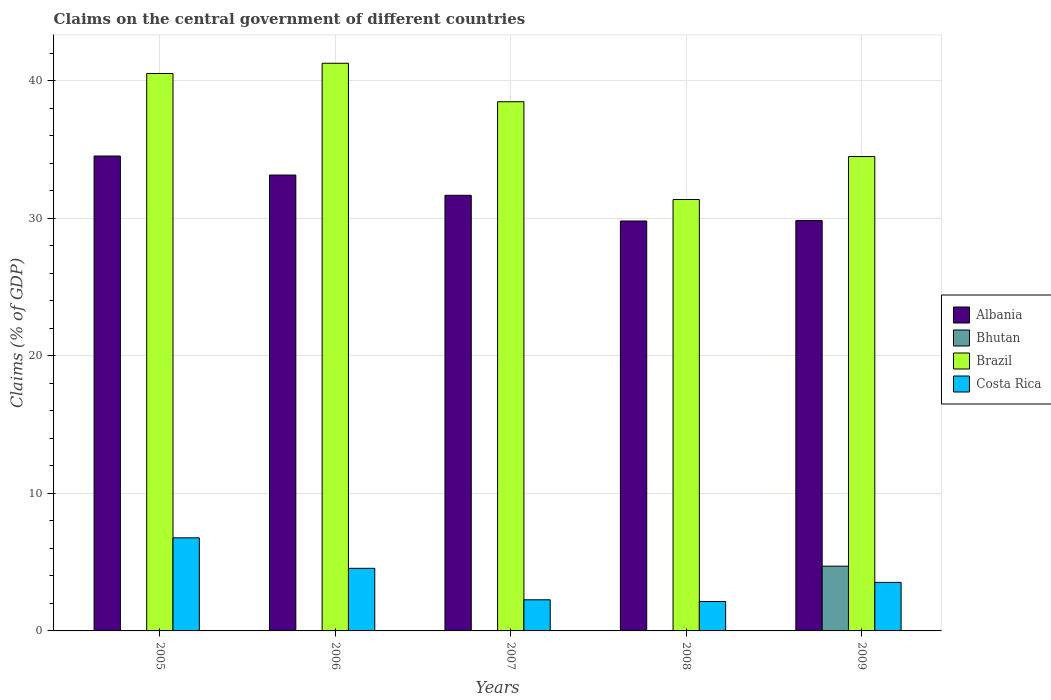How many different coloured bars are there?
Provide a short and direct response. 4. How many groups of bars are there?
Keep it short and to the point. 5. Are the number of bars per tick equal to the number of legend labels?
Provide a short and direct response. No. Are the number of bars on each tick of the X-axis equal?
Make the answer very short. No. How many bars are there on the 4th tick from the left?
Provide a succinct answer. 3. How many bars are there on the 4th tick from the right?
Give a very brief answer. 3. What is the percentage of GDP claimed on the central government in Brazil in 2005?
Give a very brief answer. 40.53. Across all years, what is the maximum percentage of GDP claimed on the central government in Brazil?
Ensure brevity in your answer.  41.27. Across all years, what is the minimum percentage of GDP claimed on the central government in Albania?
Keep it short and to the point. 29.8. In which year was the percentage of GDP claimed on the central government in Costa Rica maximum?
Your answer should be very brief. 2005. What is the total percentage of GDP claimed on the central government in Brazil in the graph?
Keep it short and to the point. 186.13. What is the difference between the percentage of GDP claimed on the central government in Costa Rica in 2005 and that in 2008?
Your response must be concise. 4.63. What is the difference between the percentage of GDP claimed on the central government in Albania in 2005 and the percentage of GDP claimed on the central government in Costa Rica in 2009?
Provide a short and direct response. 31. What is the average percentage of GDP claimed on the central government in Brazil per year?
Offer a very short reply. 37.23. In the year 2006, what is the difference between the percentage of GDP claimed on the central government in Costa Rica and percentage of GDP claimed on the central government in Brazil?
Provide a short and direct response. -36.72. What is the ratio of the percentage of GDP claimed on the central government in Brazil in 2006 to that in 2008?
Your response must be concise. 1.32. Is the percentage of GDP claimed on the central government in Costa Rica in 2006 less than that in 2009?
Your response must be concise. No. Is the difference between the percentage of GDP claimed on the central government in Costa Rica in 2005 and 2008 greater than the difference between the percentage of GDP claimed on the central government in Brazil in 2005 and 2008?
Offer a terse response. No. What is the difference between the highest and the second highest percentage of GDP claimed on the central government in Costa Rica?
Your response must be concise. 2.22. What is the difference between the highest and the lowest percentage of GDP claimed on the central government in Costa Rica?
Ensure brevity in your answer.  4.63. How many bars are there?
Provide a short and direct response. 16. Are all the bars in the graph horizontal?
Offer a very short reply. No. How many years are there in the graph?
Offer a terse response. 5. Does the graph contain any zero values?
Ensure brevity in your answer.  Yes. Does the graph contain grids?
Your answer should be very brief. Yes. How many legend labels are there?
Ensure brevity in your answer.  4. What is the title of the graph?
Offer a very short reply. Claims on the central government of different countries. Does "Madagascar" appear as one of the legend labels in the graph?
Make the answer very short. No. What is the label or title of the X-axis?
Your answer should be very brief. Years. What is the label or title of the Y-axis?
Offer a very short reply. Claims (% of GDP). What is the Claims (% of GDP) in Albania in 2005?
Offer a very short reply. 34.53. What is the Claims (% of GDP) of Bhutan in 2005?
Your answer should be compact. 0. What is the Claims (% of GDP) of Brazil in 2005?
Your answer should be very brief. 40.53. What is the Claims (% of GDP) of Costa Rica in 2005?
Your response must be concise. 6.77. What is the Claims (% of GDP) in Albania in 2006?
Keep it short and to the point. 33.14. What is the Claims (% of GDP) in Brazil in 2006?
Make the answer very short. 41.27. What is the Claims (% of GDP) in Costa Rica in 2006?
Offer a very short reply. 4.55. What is the Claims (% of GDP) of Albania in 2007?
Ensure brevity in your answer.  31.67. What is the Claims (% of GDP) in Bhutan in 2007?
Make the answer very short. 0. What is the Claims (% of GDP) in Brazil in 2007?
Provide a succinct answer. 38.47. What is the Claims (% of GDP) of Costa Rica in 2007?
Your answer should be very brief. 2.26. What is the Claims (% of GDP) of Albania in 2008?
Offer a terse response. 29.8. What is the Claims (% of GDP) in Brazil in 2008?
Provide a short and direct response. 31.37. What is the Claims (% of GDP) in Costa Rica in 2008?
Your answer should be compact. 2.14. What is the Claims (% of GDP) of Albania in 2009?
Offer a terse response. 29.83. What is the Claims (% of GDP) of Bhutan in 2009?
Provide a short and direct response. 4.71. What is the Claims (% of GDP) in Brazil in 2009?
Provide a succinct answer. 34.49. What is the Claims (% of GDP) in Costa Rica in 2009?
Ensure brevity in your answer.  3.53. Across all years, what is the maximum Claims (% of GDP) in Albania?
Offer a very short reply. 34.53. Across all years, what is the maximum Claims (% of GDP) of Bhutan?
Offer a terse response. 4.71. Across all years, what is the maximum Claims (% of GDP) of Brazil?
Provide a short and direct response. 41.27. Across all years, what is the maximum Claims (% of GDP) in Costa Rica?
Ensure brevity in your answer.  6.77. Across all years, what is the minimum Claims (% of GDP) of Albania?
Offer a very short reply. 29.8. Across all years, what is the minimum Claims (% of GDP) in Bhutan?
Offer a very short reply. 0. Across all years, what is the minimum Claims (% of GDP) of Brazil?
Offer a very short reply. 31.37. Across all years, what is the minimum Claims (% of GDP) of Costa Rica?
Ensure brevity in your answer.  2.14. What is the total Claims (% of GDP) of Albania in the graph?
Ensure brevity in your answer.  158.98. What is the total Claims (% of GDP) of Bhutan in the graph?
Offer a terse response. 4.71. What is the total Claims (% of GDP) of Brazil in the graph?
Make the answer very short. 186.13. What is the total Claims (% of GDP) of Costa Rica in the graph?
Your answer should be compact. 19.25. What is the difference between the Claims (% of GDP) in Albania in 2005 and that in 2006?
Give a very brief answer. 1.38. What is the difference between the Claims (% of GDP) in Brazil in 2005 and that in 2006?
Your response must be concise. -0.74. What is the difference between the Claims (% of GDP) of Costa Rica in 2005 and that in 2006?
Give a very brief answer. 2.22. What is the difference between the Claims (% of GDP) of Albania in 2005 and that in 2007?
Your answer should be very brief. 2.86. What is the difference between the Claims (% of GDP) in Brazil in 2005 and that in 2007?
Offer a terse response. 2.05. What is the difference between the Claims (% of GDP) of Costa Rica in 2005 and that in 2007?
Provide a short and direct response. 4.5. What is the difference between the Claims (% of GDP) in Albania in 2005 and that in 2008?
Offer a very short reply. 4.72. What is the difference between the Claims (% of GDP) of Brazil in 2005 and that in 2008?
Provide a short and direct response. 9.16. What is the difference between the Claims (% of GDP) in Costa Rica in 2005 and that in 2008?
Give a very brief answer. 4.63. What is the difference between the Claims (% of GDP) in Albania in 2005 and that in 2009?
Give a very brief answer. 4.69. What is the difference between the Claims (% of GDP) in Brazil in 2005 and that in 2009?
Your answer should be compact. 6.04. What is the difference between the Claims (% of GDP) of Costa Rica in 2005 and that in 2009?
Ensure brevity in your answer.  3.24. What is the difference between the Claims (% of GDP) in Albania in 2006 and that in 2007?
Offer a very short reply. 1.47. What is the difference between the Claims (% of GDP) of Brazil in 2006 and that in 2007?
Your response must be concise. 2.8. What is the difference between the Claims (% of GDP) of Costa Rica in 2006 and that in 2007?
Offer a very short reply. 2.29. What is the difference between the Claims (% of GDP) in Albania in 2006 and that in 2008?
Your answer should be compact. 3.34. What is the difference between the Claims (% of GDP) in Brazil in 2006 and that in 2008?
Offer a very short reply. 9.91. What is the difference between the Claims (% of GDP) in Costa Rica in 2006 and that in 2008?
Your response must be concise. 2.41. What is the difference between the Claims (% of GDP) in Albania in 2006 and that in 2009?
Offer a very short reply. 3.31. What is the difference between the Claims (% of GDP) in Brazil in 2006 and that in 2009?
Your answer should be compact. 6.78. What is the difference between the Claims (% of GDP) of Costa Rica in 2006 and that in 2009?
Provide a succinct answer. 1.02. What is the difference between the Claims (% of GDP) in Albania in 2007 and that in 2008?
Give a very brief answer. 1.87. What is the difference between the Claims (% of GDP) in Brazil in 2007 and that in 2008?
Make the answer very short. 7.11. What is the difference between the Claims (% of GDP) in Costa Rica in 2007 and that in 2008?
Provide a succinct answer. 0.12. What is the difference between the Claims (% of GDP) of Albania in 2007 and that in 2009?
Your answer should be compact. 1.84. What is the difference between the Claims (% of GDP) in Brazil in 2007 and that in 2009?
Keep it short and to the point. 3.98. What is the difference between the Claims (% of GDP) in Costa Rica in 2007 and that in 2009?
Keep it short and to the point. -1.27. What is the difference between the Claims (% of GDP) in Albania in 2008 and that in 2009?
Offer a terse response. -0.03. What is the difference between the Claims (% of GDP) in Brazil in 2008 and that in 2009?
Provide a short and direct response. -3.12. What is the difference between the Claims (% of GDP) in Costa Rica in 2008 and that in 2009?
Offer a very short reply. -1.39. What is the difference between the Claims (% of GDP) of Albania in 2005 and the Claims (% of GDP) of Brazil in 2006?
Your answer should be very brief. -6.75. What is the difference between the Claims (% of GDP) in Albania in 2005 and the Claims (% of GDP) in Costa Rica in 2006?
Your answer should be compact. 29.98. What is the difference between the Claims (% of GDP) in Brazil in 2005 and the Claims (% of GDP) in Costa Rica in 2006?
Offer a terse response. 35.98. What is the difference between the Claims (% of GDP) in Albania in 2005 and the Claims (% of GDP) in Brazil in 2007?
Keep it short and to the point. -3.95. What is the difference between the Claims (% of GDP) in Albania in 2005 and the Claims (% of GDP) in Costa Rica in 2007?
Your response must be concise. 32.26. What is the difference between the Claims (% of GDP) in Brazil in 2005 and the Claims (% of GDP) in Costa Rica in 2007?
Ensure brevity in your answer.  38.27. What is the difference between the Claims (% of GDP) of Albania in 2005 and the Claims (% of GDP) of Brazil in 2008?
Give a very brief answer. 3.16. What is the difference between the Claims (% of GDP) of Albania in 2005 and the Claims (% of GDP) of Costa Rica in 2008?
Give a very brief answer. 32.39. What is the difference between the Claims (% of GDP) in Brazil in 2005 and the Claims (% of GDP) in Costa Rica in 2008?
Your answer should be compact. 38.39. What is the difference between the Claims (% of GDP) in Albania in 2005 and the Claims (% of GDP) in Bhutan in 2009?
Ensure brevity in your answer.  29.82. What is the difference between the Claims (% of GDP) in Albania in 2005 and the Claims (% of GDP) in Brazil in 2009?
Ensure brevity in your answer.  0.04. What is the difference between the Claims (% of GDP) in Albania in 2005 and the Claims (% of GDP) in Costa Rica in 2009?
Make the answer very short. 31. What is the difference between the Claims (% of GDP) in Brazil in 2005 and the Claims (% of GDP) in Costa Rica in 2009?
Your response must be concise. 37. What is the difference between the Claims (% of GDP) in Albania in 2006 and the Claims (% of GDP) in Brazil in 2007?
Offer a terse response. -5.33. What is the difference between the Claims (% of GDP) in Albania in 2006 and the Claims (% of GDP) in Costa Rica in 2007?
Provide a short and direct response. 30.88. What is the difference between the Claims (% of GDP) of Brazil in 2006 and the Claims (% of GDP) of Costa Rica in 2007?
Ensure brevity in your answer.  39.01. What is the difference between the Claims (% of GDP) in Albania in 2006 and the Claims (% of GDP) in Brazil in 2008?
Provide a succinct answer. 1.78. What is the difference between the Claims (% of GDP) in Albania in 2006 and the Claims (% of GDP) in Costa Rica in 2008?
Provide a succinct answer. 31. What is the difference between the Claims (% of GDP) in Brazil in 2006 and the Claims (% of GDP) in Costa Rica in 2008?
Ensure brevity in your answer.  39.13. What is the difference between the Claims (% of GDP) of Albania in 2006 and the Claims (% of GDP) of Bhutan in 2009?
Your answer should be compact. 28.43. What is the difference between the Claims (% of GDP) in Albania in 2006 and the Claims (% of GDP) in Brazil in 2009?
Provide a succinct answer. -1.35. What is the difference between the Claims (% of GDP) in Albania in 2006 and the Claims (% of GDP) in Costa Rica in 2009?
Ensure brevity in your answer.  29.61. What is the difference between the Claims (% of GDP) of Brazil in 2006 and the Claims (% of GDP) of Costa Rica in 2009?
Your answer should be compact. 37.74. What is the difference between the Claims (% of GDP) of Albania in 2007 and the Claims (% of GDP) of Brazil in 2008?
Ensure brevity in your answer.  0.31. What is the difference between the Claims (% of GDP) of Albania in 2007 and the Claims (% of GDP) of Costa Rica in 2008?
Offer a terse response. 29.53. What is the difference between the Claims (% of GDP) in Brazil in 2007 and the Claims (% of GDP) in Costa Rica in 2008?
Provide a succinct answer. 36.34. What is the difference between the Claims (% of GDP) of Albania in 2007 and the Claims (% of GDP) of Bhutan in 2009?
Your response must be concise. 26.96. What is the difference between the Claims (% of GDP) of Albania in 2007 and the Claims (% of GDP) of Brazil in 2009?
Ensure brevity in your answer.  -2.82. What is the difference between the Claims (% of GDP) in Albania in 2007 and the Claims (% of GDP) in Costa Rica in 2009?
Give a very brief answer. 28.14. What is the difference between the Claims (% of GDP) in Brazil in 2007 and the Claims (% of GDP) in Costa Rica in 2009?
Your answer should be compact. 34.95. What is the difference between the Claims (% of GDP) of Albania in 2008 and the Claims (% of GDP) of Bhutan in 2009?
Offer a very short reply. 25.09. What is the difference between the Claims (% of GDP) of Albania in 2008 and the Claims (% of GDP) of Brazil in 2009?
Your answer should be compact. -4.69. What is the difference between the Claims (% of GDP) of Albania in 2008 and the Claims (% of GDP) of Costa Rica in 2009?
Ensure brevity in your answer.  26.27. What is the difference between the Claims (% of GDP) of Brazil in 2008 and the Claims (% of GDP) of Costa Rica in 2009?
Your response must be concise. 27.84. What is the average Claims (% of GDP) of Albania per year?
Your answer should be compact. 31.8. What is the average Claims (% of GDP) of Bhutan per year?
Your answer should be compact. 0.94. What is the average Claims (% of GDP) of Brazil per year?
Make the answer very short. 37.23. What is the average Claims (% of GDP) of Costa Rica per year?
Make the answer very short. 3.85. In the year 2005, what is the difference between the Claims (% of GDP) in Albania and Claims (% of GDP) in Brazil?
Ensure brevity in your answer.  -6. In the year 2005, what is the difference between the Claims (% of GDP) of Albania and Claims (% of GDP) of Costa Rica?
Provide a succinct answer. 27.76. In the year 2005, what is the difference between the Claims (% of GDP) of Brazil and Claims (% of GDP) of Costa Rica?
Make the answer very short. 33.76. In the year 2006, what is the difference between the Claims (% of GDP) of Albania and Claims (% of GDP) of Brazil?
Offer a terse response. -8.13. In the year 2006, what is the difference between the Claims (% of GDP) of Albania and Claims (% of GDP) of Costa Rica?
Give a very brief answer. 28.59. In the year 2006, what is the difference between the Claims (% of GDP) in Brazil and Claims (% of GDP) in Costa Rica?
Offer a very short reply. 36.72. In the year 2007, what is the difference between the Claims (% of GDP) of Albania and Claims (% of GDP) of Brazil?
Your answer should be compact. -6.8. In the year 2007, what is the difference between the Claims (% of GDP) of Albania and Claims (% of GDP) of Costa Rica?
Your response must be concise. 29.41. In the year 2007, what is the difference between the Claims (% of GDP) of Brazil and Claims (% of GDP) of Costa Rica?
Ensure brevity in your answer.  36.21. In the year 2008, what is the difference between the Claims (% of GDP) in Albania and Claims (% of GDP) in Brazil?
Provide a short and direct response. -1.56. In the year 2008, what is the difference between the Claims (% of GDP) in Albania and Claims (% of GDP) in Costa Rica?
Offer a very short reply. 27.66. In the year 2008, what is the difference between the Claims (% of GDP) in Brazil and Claims (% of GDP) in Costa Rica?
Ensure brevity in your answer.  29.23. In the year 2009, what is the difference between the Claims (% of GDP) of Albania and Claims (% of GDP) of Bhutan?
Your answer should be very brief. 25.13. In the year 2009, what is the difference between the Claims (% of GDP) in Albania and Claims (% of GDP) in Brazil?
Offer a terse response. -4.66. In the year 2009, what is the difference between the Claims (% of GDP) of Albania and Claims (% of GDP) of Costa Rica?
Make the answer very short. 26.31. In the year 2009, what is the difference between the Claims (% of GDP) of Bhutan and Claims (% of GDP) of Brazil?
Offer a terse response. -29.78. In the year 2009, what is the difference between the Claims (% of GDP) of Bhutan and Claims (% of GDP) of Costa Rica?
Your answer should be very brief. 1.18. In the year 2009, what is the difference between the Claims (% of GDP) of Brazil and Claims (% of GDP) of Costa Rica?
Your answer should be very brief. 30.96. What is the ratio of the Claims (% of GDP) of Albania in 2005 to that in 2006?
Your response must be concise. 1.04. What is the ratio of the Claims (% of GDP) of Costa Rica in 2005 to that in 2006?
Offer a very short reply. 1.49. What is the ratio of the Claims (% of GDP) of Albania in 2005 to that in 2007?
Your response must be concise. 1.09. What is the ratio of the Claims (% of GDP) of Brazil in 2005 to that in 2007?
Offer a terse response. 1.05. What is the ratio of the Claims (% of GDP) in Costa Rica in 2005 to that in 2007?
Your response must be concise. 2.99. What is the ratio of the Claims (% of GDP) of Albania in 2005 to that in 2008?
Your response must be concise. 1.16. What is the ratio of the Claims (% of GDP) in Brazil in 2005 to that in 2008?
Your response must be concise. 1.29. What is the ratio of the Claims (% of GDP) in Costa Rica in 2005 to that in 2008?
Your answer should be compact. 3.16. What is the ratio of the Claims (% of GDP) in Albania in 2005 to that in 2009?
Give a very brief answer. 1.16. What is the ratio of the Claims (% of GDP) in Brazil in 2005 to that in 2009?
Your answer should be very brief. 1.18. What is the ratio of the Claims (% of GDP) in Costa Rica in 2005 to that in 2009?
Offer a very short reply. 1.92. What is the ratio of the Claims (% of GDP) of Albania in 2006 to that in 2007?
Ensure brevity in your answer.  1.05. What is the ratio of the Claims (% of GDP) of Brazil in 2006 to that in 2007?
Your answer should be compact. 1.07. What is the ratio of the Claims (% of GDP) of Costa Rica in 2006 to that in 2007?
Offer a terse response. 2.01. What is the ratio of the Claims (% of GDP) in Albania in 2006 to that in 2008?
Keep it short and to the point. 1.11. What is the ratio of the Claims (% of GDP) in Brazil in 2006 to that in 2008?
Ensure brevity in your answer.  1.32. What is the ratio of the Claims (% of GDP) of Costa Rica in 2006 to that in 2008?
Give a very brief answer. 2.13. What is the ratio of the Claims (% of GDP) in Albania in 2006 to that in 2009?
Offer a very short reply. 1.11. What is the ratio of the Claims (% of GDP) of Brazil in 2006 to that in 2009?
Your response must be concise. 1.2. What is the ratio of the Claims (% of GDP) in Costa Rica in 2006 to that in 2009?
Offer a terse response. 1.29. What is the ratio of the Claims (% of GDP) in Albania in 2007 to that in 2008?
Keep it short and to the point. 1.06. What is the ratio of the Claims (% of GDP) in Brazil in 2007 to that in 2008?
Give a very brief answer. 1.23. What is the ratio of the Claims (% of GDP) of Costa Rica in 2007 to that in 2008?
Offer a terse response. 1.06. What is the ratio of the Claims (% of GDP) of Albania in 2007 to that in 2009?
Your response must be concise. 1.06. What is the ratio of the Claims (% of GDP) of Brazil in 2007 to that in 2009?
Offer a very short reply. 1.12. What is the ratio of the Claims (% of GDP) in Costa Rica in 2007 to that in 2009?
Offer a very short reply. 0.64. What is the ratio of the Claims (% of GDP) of Albania in 2008 to that in 2009?
Your answer should be compact. 1. What is the ratio of the Claims (% of GDP) of Brazil in 2008 to that in 2009?
Ensure brevity in your answer.  0.91. What is the ratio of the Claims (% of GDP) of Costa Rica in 2008 to that in 2009?
Your response must be concise. 0.61. What is the difference between the highest and the second highest Claims (% of GDP) in Albania?
Ensure brevity in your answer.  1.38. What is the difference between the highest and the second highest Claims (% of GDP) of Brazil?
Your answer should be compact. 0.74. What is the difference between the highest and the second highest Claims (% of GDP) in Costa Rica?
Offer a terse response. 2.22. What is the difference between the highest and the lowest Claims (% of GDP) in Albania?
Your answer should be compact. 4.72. What is the difference between the highest and the lowest Claims (% of GDP) in Bhutan?
Ensure brevity in your answer.  4.71. What is the difference between the highest and the lowest Claims (% of GDP) of Brazil?
Ensure brevity in your answer.  9.91. What is the difference between the highest and the lowest Claims (% of GDP) in Costa Rica?
Keep it short and to the point. 4.63. 